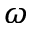Convert formula to latex. <formula><loc_0><loc_0><loc_500><loc_500>\omega</formula> 